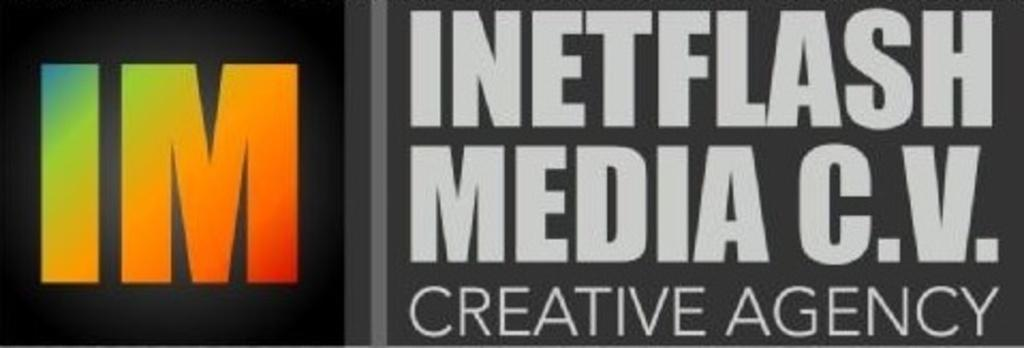What can be seen in the image that contains written information? There is text written in the image. What color is the background of the text? The background of the text is black. What type of quiver is visible in the image? There is no quiver present in the image. How many masses can be seen in the image? There is no reference to any masses in the image. 